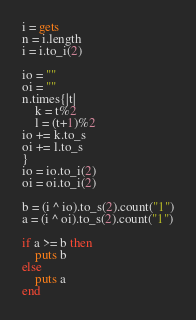<code> <loc_0><loc_0><loc_500><loc_500><_Ruby_>i = gets
n = i.length
i = i.to_i(2)

io = ""
oi = ""
n.times{|t|
    k = t%2
    l = (t+1)%2
io += k.to_s
oi += l.to_s
}
io = io.to_i(2)
oi = oi.to_i(2)

b = (i ^ io).to_s(2).count("1")
a = (i ^ oi).to_s(2).count("1")

if a >= b then
    puts b
else
    puts a
end
</code> 